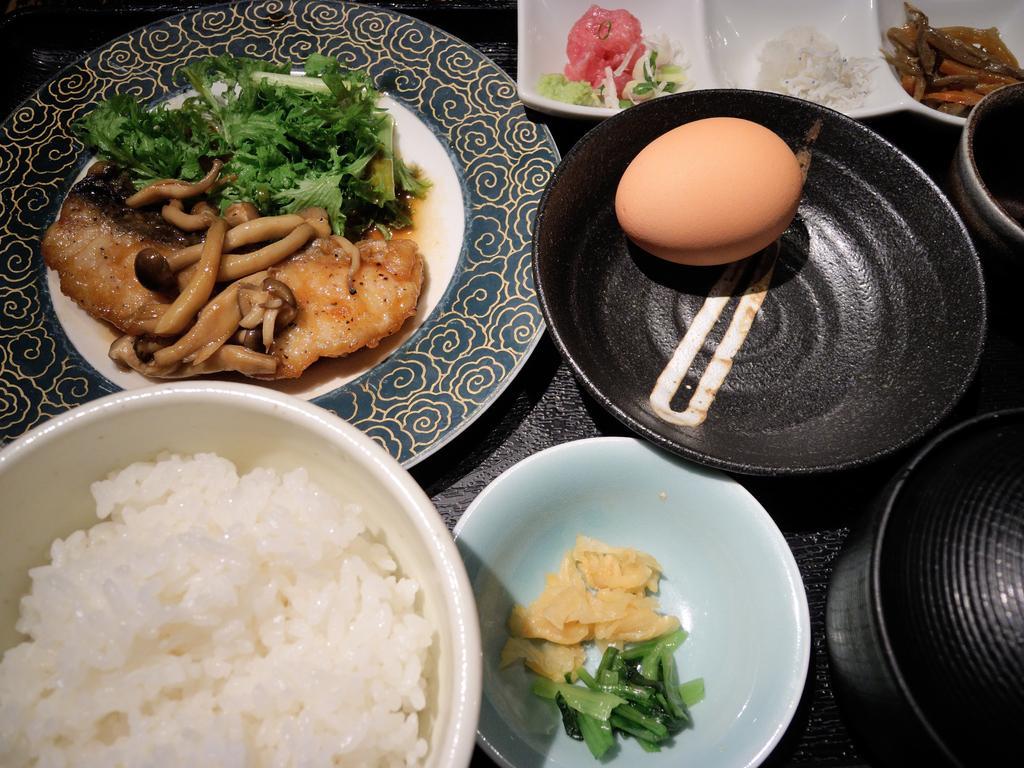Can you describe this image briefly? In this image we can see rice kept in the white color bowl, some food item kept on the plate, egg kept in the black color bowl, some food item kept in the white color bowl and some more food kept on the white plate. Here we can see two black color bowls which are placed on the wooden table. 